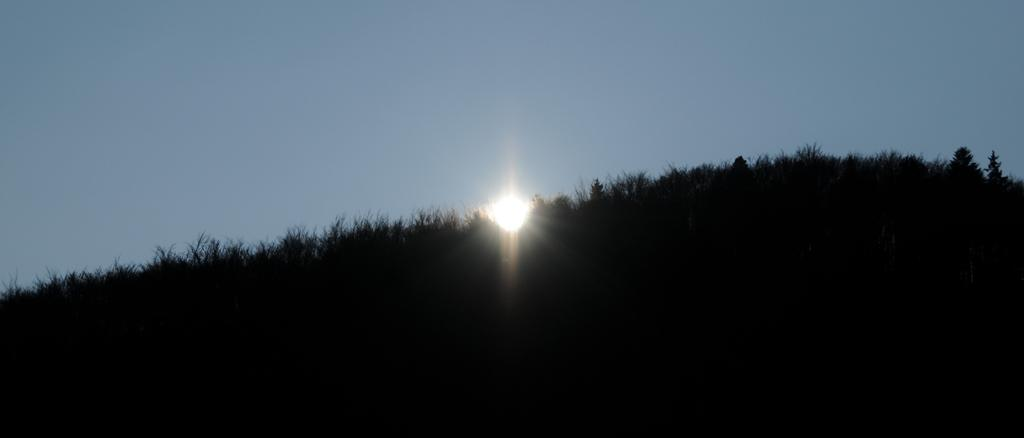What type of vegetation can be seen in the image? There are trees in the image. What is visible in the background of the image? The sky is visible in the image. Can the sun be seen in the image? Yes, the sun is observable in the sky. How many fingers can be seen pointing at the sun in the image? There are no fingers visible in the image, as it features trees and the sky. 